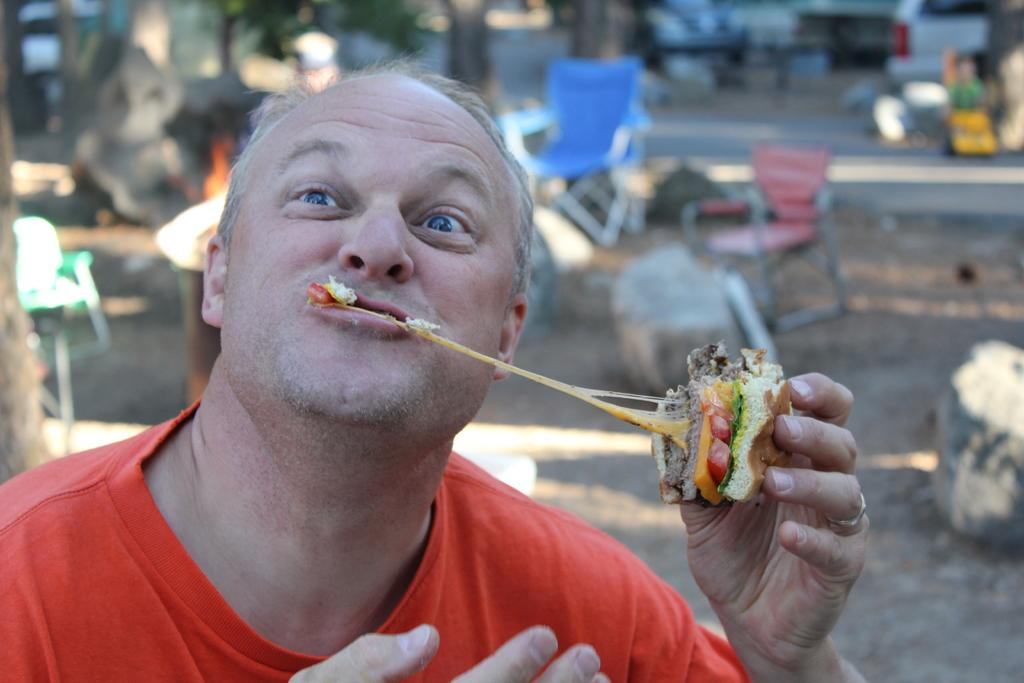What is the person in the image doing? The person is eating in the image. What is the person holding while eating? The person is holding a food item in the image. Can you describe the background of the image? The background of the image is blurred. What type of seating is present in the image? Chairs are present in the image. What type of surface can be seen in the image? Stones are visible in the image. What type of pathway is present in the image? There is a road in the image. What type of transportation is present in the image? A vehicle is present in the image. What other objects can be seen in the image? There are other objects in the image. How many pizzas are being washed in the image? There are no pizzas present in the image, and no washing is taking place. 